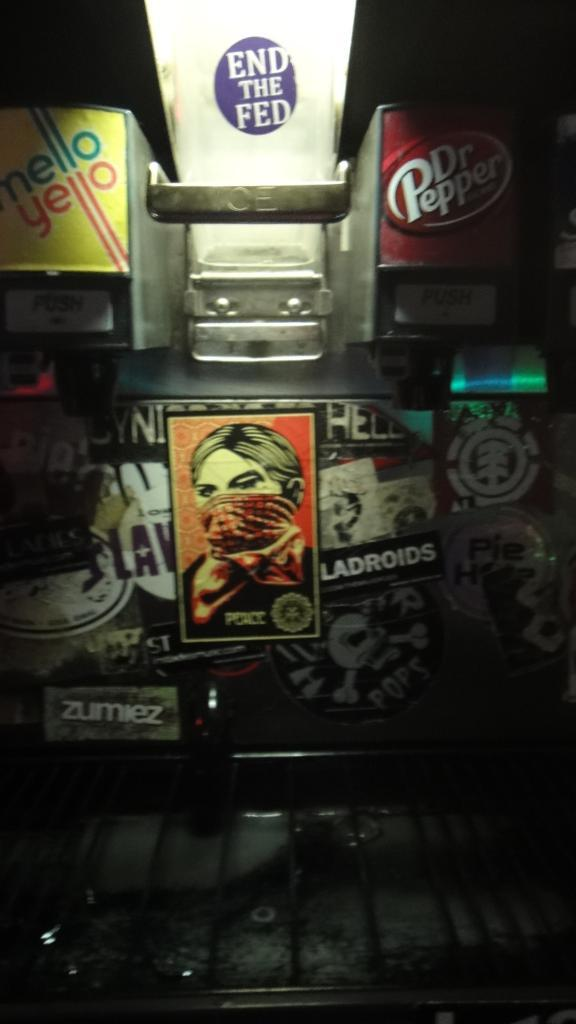<image>
Render a clear and concise summary of the photo. A fountain drink dispenser that has been sticker bombed with a sticker that says zumiez amoung others. 